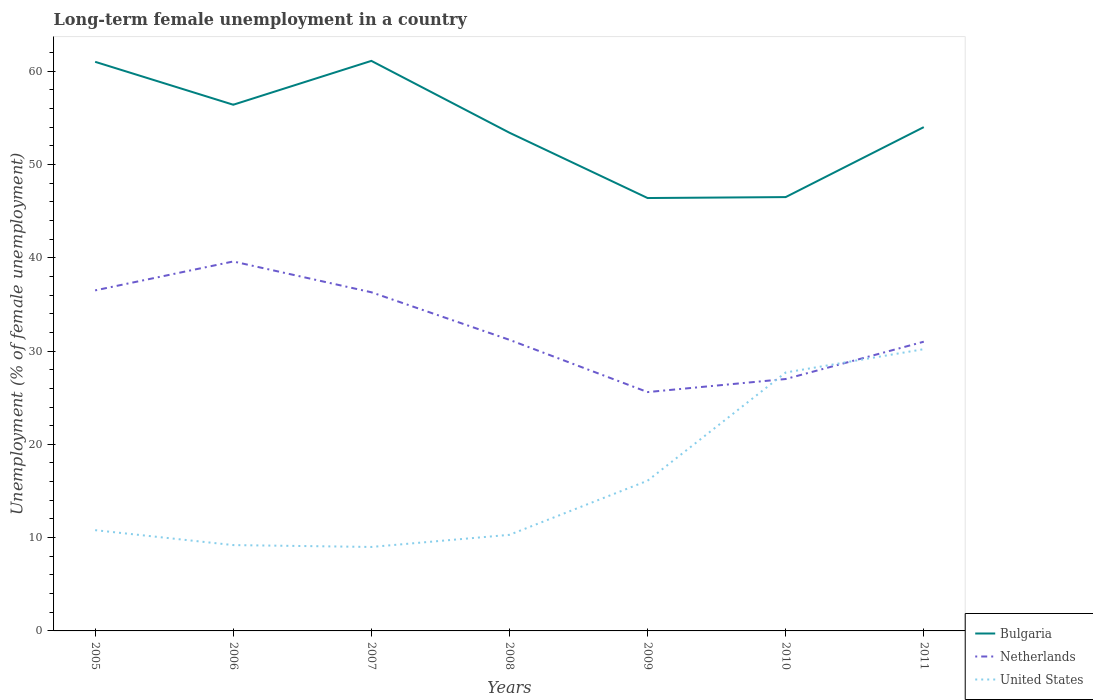How many different coloured lines are there?
Provide a succinct answer. 3. Is the number of lines equal to the number of legend labels?
Offer a terse response. Yes. Across all years, what is the maximum percentage of long-term unemployed female population in Netherlands?
Give a very brief answer. 25.6. What is the total percentage of long-term unemployed female population in Bulgaria in the graph?
Provide a succinct answer. 6.9. What is the difference between the highest and the second highest percentage of long-term unemployed female population in Netherlands?
Your answer should be very brief. 14. What is the difference between the highest and the lowest percentage of long-term unemployed female population in Netherlands?
Your answer should be very brief. 3. Is the percentage of long-term unemployed female population in United States strictly greater than the percentage of long-term unemployed female population in Bulgaria over the years?
Ensure brevity in your answer.  Yes. How many years are there in the graph?
Provide a short and direct response. 7. What is the difference between two consecutive major ticks on the Y-axis?
Provide a succinct answer. 10. Are the values on the major ticks of Y-axis written in scientific E-notation?
Ensure brevity in your answer.  No. Does the graph contain any zero values?
Ensure brevity in your answer.  No. Does the graph contain grids?
Offer a terse response. No. Where does the legend appear in the graph?
Ensure brevity in your answer.  Bottom right. What is the title of the graph?
Your answer should be very brief. Long-term female unemployment in a country. What is the label or title of the Y-axis?
Provide a short and direct response. Unemployment (% of female unemployment). What is the Unemployment (% of female unemployment) of Netherlands in 2005?
Keep it short and to the point. 36.5. What is the Unemployment (% of female unemployment) of United States in 2005?
Provide a short and direct response. 10.8. What is the Unemployment (% of female unemployment) in Bulgaria in 2006?
Your response must be concise. 56.4. What is the Unemployment (% of female unemployment) in Netherlands in 2006?
Provide a succinct answer. 39.6. What is the Unemployment (% of female unemployment) in United States in 2006?
Provide a succinct answer. 9.2. What is the Unemployment (% of female unemployment) of Bulgaria in 2007?
Your answer should be very brief. 61.1. What is the Unemployment (% of female unemployment) in Netherlands in 2007?
Your answer should be very brief. 36.3. What is the Unemployment (% of female unemployment) in United States in 2007?
Keep it short and to the point. 9. What is the Unemployment (% of female unemployment) in Bulgaria in 2008?
Ensure brevity in your answer.  53.4. What is the Unemployment (% of female unemployment) in Netherlands in 2008?
Provide a succinct answer. 31.2. What is the Unemployment (% of female unemployment) in United States in 2008?
Your answer should be compact. 10.3. What is the Unemployment (% of female unemployment) in Bulgaria in 2009?
Your answer should be very brief. 46.4. What is the Unemployment (% of female unemployment) of Netherlands in 2009?
Give a very brief answer. 25.6. What is the Unemployment (% of female unemployment) in United States in 2009?
Your answer should be very brief. 16.1. What is the Unemployment (% of female unemployment) in Bulgaria in 2010?
Offer a very short reply. 46.5. What is the Unemployment (% of female unemployment) in Netherlands in 2010?
Offer a terse response. 27. What is the Unemployment (% of female unemployment) in United States in 2010?
Offer a very short reply. 27.7. What is the Unemployment (% of female unemployment) of Bulgaria in 2011?
Your answer should be very brief. 54. What is the Unemployment (% of female unemployment) in United States in 2011?
Offer a very short reply. 30.2. Across all years, what is the maximum Unemployment (% of female unemployment) in Bulgaria?
Make the answer very short. 61.1. Across all years, what is the maximum Unemployment (% of female unemployment) of Netherlands?
Your response must be concise. 39.6. Across all years, what is the maximum Unemployment (% of female unemployment) of United States?
Provide a succinct answer. 30.2. Across all years, what is the minimum Unemployment (% of female unemployment) in Bulgaria?
Make the answer very short. 46.4. Across all years, what is the minimum Unemployment (% of female unemployment) in Netherlands?
Keep it short and to the point. 25.6. What is the total Unemployment (% of female unemployment) in Bulgaria in the graph?
Your answer should be very brief. 378.8. What is the total Unemployment (% of female unemployment) of Netherlands in the graph?
Provide a succinct answer. 227.2. What is the total Unemployment (% of female unemployment) of United States in the graph?
Provide a succinct answer. 113.3. What is the difference between the Unemployment (% of female unemployment) of Netherlands in 2005 and that in 2007?
Provide a succinct answer. 0.2. What is the difference between the Unemployment (% of female unemployment) in United States in 2005 and that in 2007?
Make the answer very short. 1.8. What is the difference between the Unemployment (% of female unemployment) in Bulgaria in 2005 and that in 2008?
Ensure brevity in your answer.  7.6. What is the difference between the Unemployment (% of female unemployment) in Netherlands in 2005 and that in 2009?
Provide a short and direct response. 10.9. What is the difference between the Unemployment (% of female unemployment) of United States in 2005 and that in 2009?
Your answer should be compact. -5.3. What is the difference between the Unemployment (% of female unemployment) of United States in 2005 and that in 2010?
Provide a short and direct response. -16.9. What is the difference between the Unemployment (% of female unemployment) in Bulgaria in 2005 and that in 2011?
Offer a very short reply. 7. What is the difference between the Unemployment (% of female unemployment) in United States in 2005 and that in 2011?
Make the answer very short. -19.4. What is the difference between the Unemployment (% of female unemployment) in Netherlands in 2006 and that in 2007?
Your response must be concise. 3.3. What is the difference between the Unemployment (% of female unemployment) of United States in 2006 and that in 2007?
Give a very brief answer. 0.2. What is the difference between the Unemployment (% of female unemployment) in Bulgaria in 2006 and that in 2009?
Your response must be concise. 10. What is the difference between the Unemployment (% of female unemployment) in United States in 2006 and that in 2009?
Keep it short and to the point. -6.9. What is the difference between the Unemployment (% of female unemployment) of Netherlands in 2006 and that in 2010?
Give a very brief answer. 12.6. What is the difference between the Unemployment (% of female unemployment) in United States in 2006 and that in 2010?
Your answer should be compact. -18.5. What is the difference between the Unemployment (% of female unemployment) in Bulgaria in 2006 and that in 2011?
Ensure brevity in your answer.  2.4. What is the difference between the Unemployment (% of female unemployment) of United States in 2006 and that in 2011?
Ensure brevity in your answer.  -21. What is the difference between the Unemployment (% of female unemployment) in Netherlands in 2007 and that in 2008?
Offer a very short reply. 5.1. What is the difference between the Unemployment (% of female unemployment) of Netherlands in 2007 and that in 2009?
Offer a very short reply. 10.7. What is the difference between the Unemployment (% of female unemployment) in United States in 2007 and that in 2009?
Your answer should be very brief. -7.1. What is the difference between the Unemployment (% of female unemployment) of Bulgaria in 2007 and that in 2010?
Provide a succinct answer. 14.6. What is the difference between the Unemployment (% of female unemployment) of Netherlands in 2007 and that in 2010?
Your answer should be compact. 9.3. What is the difference between the Unemployment (% of female unemployment) in United States in 2007 and that in 2010?
Give a very brief answer. -18.7. What is the difference between the Unemployment (% of female unemployment) in Bulgaria in 2007 and that in 2011?
Offer a very short reply. 7.1. What is the difference between the Unemployment (% of female unemployment) in Netherlands in 2007 and that in 2011?
Give a very brief answer. 5.3. What is the difference between the Unemployment (% of female unemployment) in United States in 2007 and that in 2011?
Offer a terse response. -21.2. What is the difference between the Unemployment (% of female unemployment) in Bulgaria in 2008 and that in 2009?
Offer a terse response. 7. What is the difference between the Unemployment (% of female unemployment) in Netherlands in 2008 and that in 2009?
Offer a terse response. 5.6. What is the difference between the Unemployment (% of female unemployment) of Bulgaria in 2008 and that in 2010?
Your answer should be compact. 6.9. What is the difference between the Unemployment (% of female unemployment) of United States in 2008 and that in 2010?
Provide a short and direct response. -17.4. What is the difference between the Unemployment (% of female unemployment) in Bulgaria in 2008 and that in 2011?
Your response must be concise. -0.6. What is the difference between the Unemployment (% of female unemployment) in United States in 2008 and that in 2011?
Make the answer very short. -19.9. What is the difference between the Unemployment (% of female unemployment) of Bulgaria in 2009 and that in 2010?
Your response must be concise. -0.1. What is the difference between the Unemployment (% of female unemployment) of United States in 2009 and that in 2010?
Provide a succinct answer. -11.6. What is the difference between the Unemployment (% of female unemployment) of Bulgaria in 2009 and that in 2011?
Provide a short and direct response. -7.6. What is the difference between the Unemployment (% of female unemployment) in United States in 2009 and that in 2011?
Your answer should be very brief. -14.1. What is the difference between the Unemployment (% of female unemployment) in United States in 2010 and that in 2011?
Offer a terse response. -2.5. What is the difference between the Unemployment (% of female unemployment) in Bulgaria in 2005 and the Unemployment (% of female unemployment) in Netherlands in 2006?
Your answer should be compact. 21.4. What is the difference between the Unemployment (% of female unemployment) of Bulgaria in 2005 and the Unemployment (% of female unemployment) of United States in 2006?
Provide a succinct answer. 51.8. What is the difference between the Unemployment (% of female unemployment) in Netherlands in 2005 and the Unemployment (% of female unemployment) in United States in 2006?
Give a very brief answer. 27.3. What is the difference between the Unemployment (% of female unemployment) in Bulgaria in 2005 and the Unemployment (% of female unemployment) in Netherlands in 2007?
Make the answer very short. 24.7. What is the difference between the Unemployment (% of female unemployment) of Bulgaria in 2005 and the Unemployment (% of female unemployment) of Netherlands in 2008?
Your answer should be compact. 29.8. What is the difference between the Unemployment (% of female unemployment) of Bulgaria in 2005 and the Unemployment (% of female unemployment) of United States in 2008?
Keep it short and to the point. 50.7. What is the difference between the Unemployment (% of female unemployment) in Netherlands in 2005 and the Unemployment (% of female unemployment) in United States in 2008?
Offer a terse response. 26.2. What is the difference between the Unemployment (% of female unemployment) of Bulgaria in 2005 and the Unemployment (% of female unemployment) of Netherlands in 2009?
Offer a very short reply. 35.4. What is the difference between the Unemployment (% of female unemployment) in Bulgaria in 2005 and the Unemployment (% of female unemployment) in United States in 2009?
Provide a short and direct response. 44.9. What is the difference between the Unemployment (% of female unemployment) of Netherlands in 2005 and the Unemployment (% of female unemployment) of United States in 2009?
Provide a succinct answer. 20.4. What is the difference between the Unemployment (% of female unemployment) of Bulgaria in 2005 and the Unemployment (% of female unemployment) of Netherlands in 2010?
Give a very brief answer. 34. What is the difference between the Unemployment (% of female unemployment) in Bulgaria in 2005 and the Unemployment (% of female unemployment) in United States in 2010?
Offer a very short reply. 33.3. What is the difference between the Unemployment (% of female unemployment) of Netherlands in 2005 and the Unemployment (% of female unemployment) of United States in 2010?
Your response must be concise. 8.8. What is the difference between the Unemployment (% of female unemployment) of Bulgaria in 2005 and the Unemployment (% of female unemployment) of Netherlands in 2011?
Your answer should be very brief. 30. What is the difference between the Unemployment (% of female unemployment) of Bulgaria in 2005 and the Unemployment (% of female unemployment) of United States in 2011?
Keep it short and to the point. 30.8. What is the difference between the Unemployment (% of female unemployment) of Bulgaria in 2006 and the Unemployment (% of female unemployment) of Netherlands in 2007?
Offer a terse response. 20.1. What is the difference between the Unemployment (% of female unemployment) in Bulgaria in 2006 and the Unemployment (% of female unemployment) in United States in 2007?
Ensure brevity in your answer.  47.4. What is the difference between the Unemployment (% of female unemployment) in Netherlands in 2006 and the Unemployment (% of female unemployment) in United States in 2007?
Keep it short and to the point. 30.6. What is the difference between the Unemployment (% of female unemployment) in Bulgaria in 2006 and the Unemployment (% of female unemployment) in Netherlands in 2008?
Ensure brevity in your answer.  25.2. What is the difference between the Unemployment (% of female unemployment) of Bulgaria in 2006 and the Unemployment (% of female unemployment) of United States in 2008?
Your answer should be very brief. 46.1. What is the difference between the Unemployment (% of female unemployment) in Netherlands in 2006 and the Unemployment (% of female unemployment) in United States in 2008?
Offer a terse response. 29.3. What is the difference between the Unemployment (% of female unemployment) in Bulgaria in 2006 and the Unemployment (% of female unemployment) in Netherlands in 2009?
Provide a short and direct response. 30.8. What is the difference between the Unemployment (% of female unemployment) of Bulgaria in 2006 and the Unemployment (% of female unemployment) of United States in 2009?
Provide a short and direct response. 40.3. What is the difference between the Unemployment (% of female unemployment) of Netherlands in 2006 and the Unemployment (% of female unemployment) of United States in 2009?
Give a very brief answer. 23.5. What is the difference between the Unemployment (% of female unemployment) of Bulgaria in 2006 and the Unemployment (% of female unemployment) of Netherlands in 2010?
Give a very brief answer. 29.4. What is the difference between the Unemployment (% of female unemployment) in Bulgaria in 2006 and the Unemployment (% of female unemployment) in United States in 2010?
Offer a terse response. 28.7. What is the difference between the Unemployment (% of female unemployment) in Netherlands in 2006 and the Unemployment (% of female unemployment) in United States in 2010?
Keep it short and to the point. 11.9. What is the difference between the Unemployment (% of female unemployment) in Bulgaria in 2006 and the Unemployment (% of female unemployment) in Netherlands in 2011?
Offer a terse response. 25.4. What is the difference between the Unemployment (% of female unemployment) in Bulgaria in 2006 and the Unemployment (% of female unemployment) in United States in 2011?
Keep it short and to the point. 26.2. What is the difference between the Unemployment (% of female unemployment) of Netherlands in 2006 and the Unemployment (% of female unemployment) of United States in 2011?
Give a very brief answer. 9.4. What is the difference between the Unemployment (% of female unemployment) in Bulgaria in 2007 and the Unemployment (% of female unemployment) in Netherlands in 2008?
Your answer should be compact. 29.9. What is the difference between the Unemployment (% of female unemployment) in Bulgaria in 2007 and the Unemployment (% of female unemployment) in United States in 2008?
Provide a succinct answer. 50.8. What is the difference between the Unemployment (% of female unemployment) in Netherlands in 2007 and the Unemployment (% of female unemployment) in United States in 2008?
Your response must be concise. 26. What is the difference between the Unemployment (% of female unemployment) of Bulgaria in 2007 and the Unemployment (% of female unemployment) of Netherlands in 2009?
Give a very brief answer. 35.5. What is the difference between the Unemployment (% of female unemployment) of Bulgaria in 2007 and the Unemployment (% of female unemployment) of United States in 2009?
Your answer should be compact. 45. What is the difference between the Unemployment (% of female unemployment) in Netherlands in 2007 and the Unemployment (% of female unemployment) in United States in 2009?
Offer a terse response. 20.2. What is the difference between the Unemployment (% of female unemployment) of Bulgaria in 2007 and the Unemployment (% of female unemployment) of Netherlands in 2010?
Your answer should be compact. 34.1. What is the difference between the Unemployment (% of female unemployment) of Bulgaria in 2007 and the Unemployment (% of female unemployment) of United States in 2010?
Your answer should be very brief. 33.4. What is the difference between the Unemployment (% of female unemployment) of Netherlands in 2007 and the Unemployment (% of female unemployment) of United States in 2010?
Keep it short and to the point. 8.6. What is the difference between the Unemployment (% of female unemployment) in Bulgaria in 2007 and the Unemployment (% of female unemployment) in Netherlands in 2011?
Offer a very short reply. 30.1. What is the difference between the Unemployment (% of female unemployment) in Bulgaria in 2007 and the Unemployment (% of female unemployment) in United States in 2011?
Your response must be concise. 30.9. What is the difference between the Unemployment (% of female unemployment) in Netherlands in 2007 and the Unemployment (% of female unemployment) in United States in 2011?
Ensure brevity in your answer.  6.1. What is the difference between the Unemployment (% of female unemployment) in Bulgaria in 2008 and the Unemployment (% of female unemployment) in Netherlands in 2009?
Offer a very short reply. 27.8. What is the difference between the Unemployment (% of female unemployment) of Bulgaria in 2008 and the Unemployment (% of female unemployment) of United States in 2009?
Keep it short and to the point. 37.3. What is the difference between the Unemployment (% of female unemployment) of Bulgaria in 2008 and the Unemployment (% of female unemployment) of Netherlands in 2010?
Your response must be concise. 26.4. What is the difference between the Unemployment (% of female unemployment) of Bulgaria in 2008 and the Unemployment (% of female unemployment) of United States in 2010?
Keep it short and to the point. 25.7. What is the difference between the Unemployment (% of female unemployment) of Bulgaria in 2008 and the Unemployment (% of female unemployment) of Netherlands in 2011?
Offer a very short reply. 22.4. What is the difference between the Unemployment (% of female unemployment) in Bulgaria in 2008 and the Unemployment (% of female unemployment) in United States in 2011?
Make the answer very short. 23.2. What is the difference between the Unemployment (% of female unemployment) of Netherlands in 2008 and the Unemployment (% of female unemployment) of United States in 2011?
Ensure brevity in your answer.  1. What is the difference between the Unemployment (% of female unemployment) of Bulgaria in 2009 and the Unemployment (% of female unemployment) of United States in 2010?
Provide a succinct answer. 18.7. What is the difference between the Unemployment (% of female unemployment) in Netherlands in 2009 and the Unemployment (% of female unemployment) in United States in 2010?
Offer a terse response. -2.1. What is the difference between the Unemployment (% of female unemployment) of Netherlands in 2009 and the Unemployment (% of female unemployment) of United States in 2011?
Your answer should be compact. -4.6. What is the difference between the Unemployment (% of female unemployment) of Bulgaria in 2010 and the Unemployment (% of female unemployment) of Netherlands in 2011?
Your answer should be very brief. 15.5. What is the difference between the Unemployment (% of female unemployment) in Bulgaria in 2010 and the Unemployment (% of female unemployment) in United States in 2011?
Provide a short and direct response. 16.3. What is the difference between the Unemployment (% of female unemployment) of Netherlands in 2010 and the Unemployment (% of female unemployment) of United States in 2011?
Your answer should be very brief. -3.2. What is the average Unemployment (% of female unemployment) in Bulgaria per year?
Your answer should be very brief. 54.11. What is the average Unemployment (% of female unemployment) in Netherlands per year?
Your answer should be very brief. 32.46. What is the average Unemployment (% of female unemployment) of United States per year?
Make the answer very short. 16.19. In the year 2005, what is the difference between the Unemployment (% of female unemployment) in Bulgaria and Unemployment (% of female unemployment) in United States?
Make the answer very short. 50.2. In the year 2005, what is the difference between the Unemployment (% of female unemployment) in Netherlands and Unemployment (% of female unemployment) in United States?
Your answer should be compact. 25.7. In the year 2006, what is the difference between the Unemployment (% of female unemployment) of Bulgaria and Unemployment (% of female unemployment) of United States?
Your response must be concise. 47.2. In the year 2006, what is the difference between the Unemployment (% of female unemployment) of Netherlands and Unemployment (% of female unemployment) of United States?
Make the answer very short. 30.4. In the year 2007, what is the difference between the Unemployment (% of female unemployment) of Bulgaria and Unemployment (% of female unemployment) of Netherlands?
Offer a very short reply. 24.8. In the year 2007, what is the difference between the Unemployment (% of female unemployment) in Bulgaria and Unemployment (% of female unemployment) in United States?
Keep it short and to the point. 52.1. In the year 2007, what is the difference between the Unemployment (% of female unemployment) of Netherlands and Unemployment (% of female unemployment) of United States?
Make the answer very short. 27.3. In the year 2008, what is the difference between the Unemployment (% of female unemployment) of Bulgaria and Unemployment (% of female unemployment) of Netherlands?
Provide a short and direct response. 22.2. In the year 2008, what is the difference between the Unemployment (% of female unemployment) in Bulgaria and Unemployment (% of female unemployment) in United States?
Offer a terse response. 43.1. In the year 2008, what is the difference between the Unemployment (% of female unemployment) of Netherlands and Unemployment (% of female unemployment) of United States?
Offer a very short reply. 20.9. In the year 2009, what is the difference between the Unemployment (% of female unemployment) in Bulgaria and Unemployment (% of female unemployment) in Netherlands?
Your answer should be compact. 20.8. In the year 2009, what is the difference between the Unemployment (% of female unemployment) of Bulgaria and Unemployment (% of female unemployment) of United States?
Offer a terse response. 30.3. In the year 2009, what is the difference between the Unemployment (% of female unemployment) of Netherlands and Unemployment (% of female unemployment) of United States?
Provide a succinct answer. 9.5. In the year 2010, what is the difference between the Unemployment (% of female unemployment) in Bulgaria and Unemployment (% of female unemployment) in United States?
Provide a succinct answer. 18.8. In the year 2010, what is the difference between the Unemployment (% of female unemployment) of Netherlands and Unemployment (% of female unemployment) of United States?
Your answer should be very brief. -0.7. In the year 2011, what is the difference between the Unemployment (% of female unemployment) in Bulgaria and Unemployment (% of female unemployment) in United States?
Offer a terse response. 23.8. In the year 2011, what is the difference between the Unemployment (% of female unemployment) of Netherlands and Unemployment (% of female unemployment) of United States?
Offer a very short reply. 0.8. What is the ratio of the Unemployment (% of female unemployment) of Bulgaria in 2005 to that in 2006?
Offer a terse response. 1.08. What is the ratio of the Unemployment (% of female unemployment) in Netherlands in 2005 to that in 2006?
Provide a succinct answer. 0.92. What is the ratio of the Unemployment (% of female unemployment) of United States in 2005 to that in 2006?
Give a very brief answer. 1.17. What is the ratio of the Unemployment (% of female unemployment) of Bulgaria in 2005 to that in 2007?
Offer a very short reply. 1. What is the ratio of the Unemployment (% of female unemployment) of United States in 2005 to that in 2007?
Give a very brief answer. 1.2. What is the ratio of the Unemployment (% of female unemployment) in Bulgaria in 2005 to that in 2008?
Offer a terse response. 1.14. What is the ratio of the Unemployment (% of female unemployment) in Netherlands in 2005 to that in 2008?
Ensure brevity in your answer.  1.17. What is the ratio of the Unemployment (% of female unemployment) of United States in 2005 to that in 2008?
Your response must be concise. 1.05. What is the ratio of the Unemployment (% of female unemployment) in Bulgaria in 2005 to that in 2009?
Provide a succinct answer. 1.31. What is the ratio of the Unemployment (% of female unemployment) of Netherlands in 2005 to that in 2009?
Give a very brief answer. 1.43. What is the ratio of the Unemployment (% of female unemployment) in United States in 2005 to that in 2009?
Make the answer very short. 0.67. What is the ratio of the Unemployment (% of female unemployment) in Bulgaria in 2005 to that in 2010?
Keep it short and to the point. 1.31. What is the ratio of the Unemployment (% of female unemployment) of Netherlands in 2005 to that in 2010?
Offer a very short reply. 1.35. What is the ratio of the Unemployment (% of female unemployment) of United States in 2005 to that in 2010?
Provide a succinct answer. 0.39. What is the ratio of the Unemployment (% of female unemployment) of Bulgaria in 2005 to that in 2011?
Provide a succinct answer. 1.13. What is the ratio of the Unemployment (% of female unemployment) of Netherlands in 2005 to that in 2011?
Your answer should be very brief. 1.18. What is the ratio of the Unemployment (% of female unemployment) of United States in 2005 to that in 2011?
Provide a succinct answer. 0.36. What is the ratio of the Unemployment (% of female unemployment) of Bulgaria in 2006 to that in 2007?
Offer a very short reply. 0.92. What is the ratio of the Unemployment (% of female unemployment) in United States in 2006 to that in 2007?
Your answer should be compact. 1.02. What is the ratio of the Unemployment (% of female unemployment) of Bulgaria in 2006 to that in 2008?
Provide a short and direct response. 1.06. What is the ratio of the Unemployment (% of female unemployment) of Netherlands in 2006 to that in 2008?
Your answer should be compact. 1.27. What is the ratio of the Unemployment (% of female unemployment) in United States in 2006 to that in 2008?
Keep it short and to the point. 0.89. What is the ratio of the Unemployment (% of female unemployment) in Bulgaria in 2006 to that in 2009?
Provide a succinct answer. 1.22. What is the ratio of the Unemployment (% of female unemployment) of Netherlands in 2006 to that in 2009?
Ensure brevity in your answer.  1.55. What is the ratio of the Unemployment (% of female unemployment) in United States in 2006 to that in 2009?
Your response must be concise. 0.57. What is the ratio of the Unemployment (% of female unemployment) of Bulgaria in 2006 to that in 2010?
Offer a terse response. 1.21. What is the ratio of the Unemployment (% of female unemployment) of Netherlands in 2006 to that in 2010?
Offer a very short reply. 1.47. What is the ratio of the Unemployment (% of female unemployment) in United States in 2006 to that in 2010?
Offer a terse response. 0.33. What is the ratio of the Unemployment (% of female unemployment) in Bulgaria in 2006 to that in 2011?
Your answer should be compact. 1.04. What is the ratio of the Unemployment (% of female unemployment) in Netherlands in 2006 to that in 2011?
Keep it short and to the point. 1.28. What is the ratio of the Unemployment (% of female unemployment) of United States in 2006 to that in 2011?
Your answer should be compact. 0.3. What is the ratio of the Unemployment (% of female unemployment) of Bulgaria in 2007 to that in 2008?
Offer a very short reply. 1.14. What is the ratio of the Unemployment (% of female unemployment) of Netherlands in 2007 to that in 2008?
Provide a short and direct response. 1.16. What is the ratio of the Unemployment (% of female unemployment) in United States in 2007 to that in 2008?
Your answer should be very brief. 0.87. What is the ratio of the Unemployment (% of female unemployment) of Bulgaria in 2007 to that in 2009?
Your answer should be compact. 1.32. What is the ratio of the Unemployment (% of female unemployment) in Netherlands in 2007 to that in 2009?
Make the answer very short. 1.42. What is the ratio of the Unemployment (% of female unemployment) of United States in 2007 to that in 2009?
Make the answer very short. 0.56. What is the ratio of the Unemployment (% of female unemployment) in Bulgaria in 2007 to that in 2010?
Ensure brevity in your answer.  1.31. What is the ratio of the Unemployment (% of female unemployment) in Netherlands in 2007 to that in 2010?
Your response must be concise. 1.34. What is the ratio of the Unemployment (% of female unemployment) of United States in 2007 to that in 2010?
Your response must be concise. 0.32. What is the ratio of the Unemployment (% of female unemployment) of Bulgaria in 2007 to that in 2011?
Provide a succinct answer. 1.13. What is the ratio of the Unemployment (% of female unemployment) of Netherlands in 2007 to that in 2011?
Your answer should be compact. 1.17. What is the ratio of the Unemployment (% of female unemployment) in United States in 2007 to that in 2011?
Your answer should be very brief. 0.3. What is the ratio of the Unemployment (% of female unemployment) of Bulgaria in 2008 to that in 2009?
Your response must be concise. 1.15. What is the ratio of the Unemployment (% of female unemployment) of Netherlands in 2008 to that in 2009?
Your response must be concise. 1.22. What is the ratio of the Unemployment (% of female unemployment) of United States in 2008 to that in 2009?
Offer a terse response. 0.64. What is the ratio of the Unemployment (% of female unemployment) in Bulgaria in 2008 to that in 2010?
Offer a very short reply. 1.15. What is the ratio of the Unemployment (% of female unemployment) in Netherlands in 2008 to that in 2010?
Give a very brief answer. 1.16. What is the ratio of the Unemployment (% of female unemployment) of United States in 2008 to that in 2010?
Provide a short and direct response. 0.37. What is the ratio of the Unemployment (% of female unemployment) in Bulgaria in 2008 to that in 2011?
Provide a short and direct response. 0.99. What is the ratio of the Unemployment (% of female unemployment) of Netherlands in 2008 to that in 2011?
Your answer should be very brief. 1.01. What is the ratio of the Unemployment (% of female unemployment) in United States in 2008 to that in 2011?
Offer a terse response. 0.34. What is the ratio of the Unemployment (% of female unemployment) of Bulgaria in 2009 to that in 2010?
Keep it short and to the point. 1. What is the ratio of the Unemployment (% of female unemployment) of Netherlands in 2009 to that in 2010?
Offer a terse response. 0.95. What is the ratio of the Unemployment (% of female unemployment) of United States in 2009 to that in 2010?
Offer a terse response. 0.58. What is the ratio of the Unemployment (% of female unemployment) of Bulgaria in 2009 to that in 2011?
Offer a terse response. 0.86. What is the ratio of the Unemployment (% of female unemployment) in Netherlands in 2009 to that in 2011?
Your answer should be very brief. 0.83. What is the ratio of the Unemployment (% of female unemployment) of United States in 2009 to that in 2011?
Your answer should be compact. 0.53. What is the ratio of the Unemployment (% of female unemployment) of Bulgaria in 2010 to that in 2011?
Provide a short and direct response. 0.86. What is the ratio of the Unemployment (% of female unemployment) in Netherlands in 2010 to that in 2011?
Make the answer very short. 0.87. What is the ratio of the Unemployment (% of female unemployment) in United States in 2010 to that in 2011?
Provide a short and direct response. 0.92. What is the difference between the highest and the second highest Unemployment (% of female unemployment) of Bulgaria?
Your answer should be compact. 0.1. What is the difference between the highest and the second highest Unemployment (% of female unemployment) in United States?
Offer a very short reply. 2.5. What is the difference between the highest and the lowest Unemployment (% of female unemployment) in Bulgaria?
Your answer should be very brief. 14.7. What is the difference between the highest and the lowest Unemployment (% of female unemployment) in United States?
Offer a terse response. 21.2. 